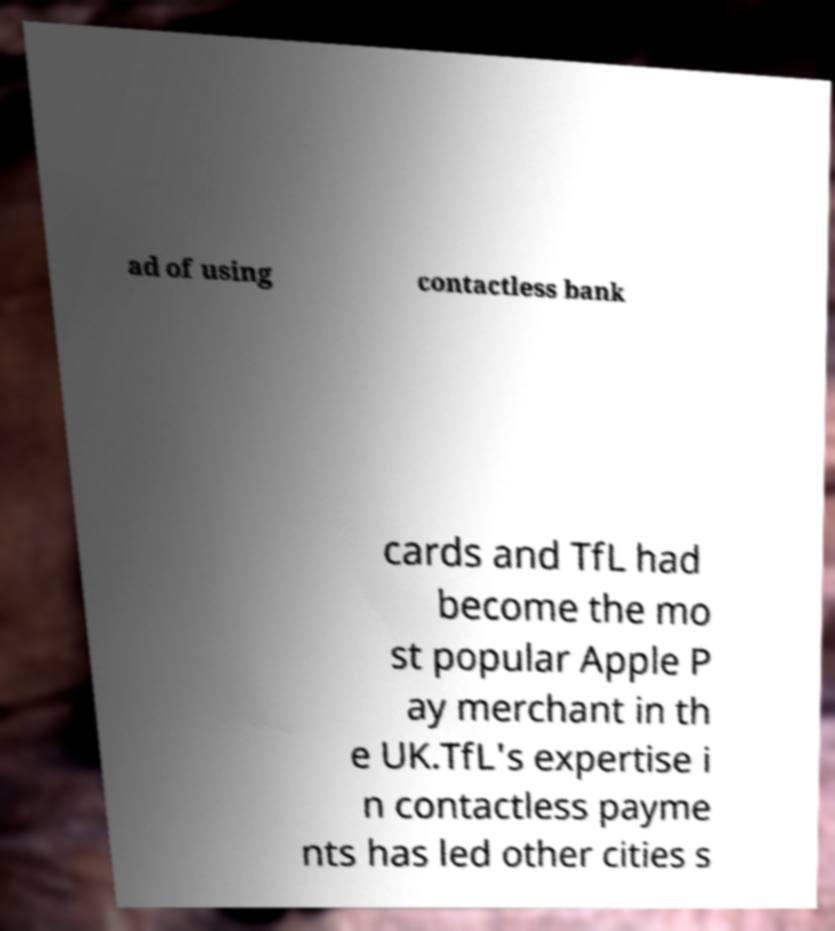Please identify and transcribe the text found in this image. ad of using contactless bank cards and TfL had become the mo st popular Apple P ay merchant in th e UK.TfL's expertise i n contactless payme nts has led other cities s 